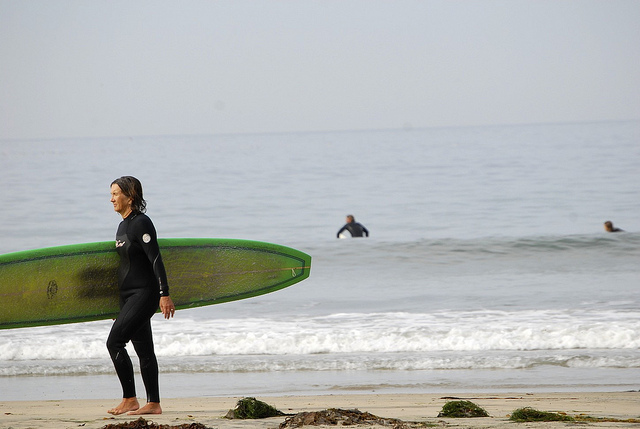What might the people be waiting for or doing based on the visual context? Based on the visual context, it appears that the individuals are engaged in surfing activities. The person in the foreground seems to be approaching the water, potentially preparing to start surfing with their surfboard in hand. The other individuals in the water might be waiting for suitable waves to surf on, with one sitting or floating on a surfboard and another waiting further out. 